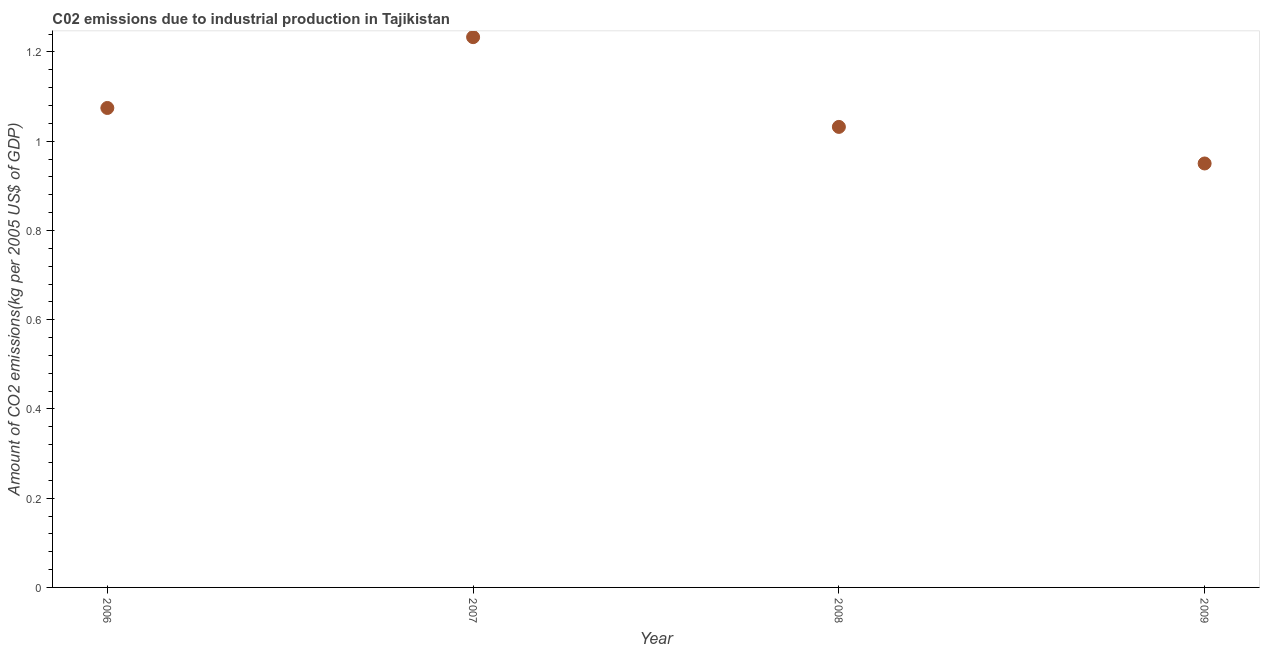What is the amount of co2 emissions in 2009?
Give a very brief answer. 0.95. Across all years, what is the maximum amount of co2 emissions?
Give a very brief answer. 1.23. Across all years, what is the minimum amount of co2 emissions?
Your response must be concise. 0.95. In which year was the amount of co2 emissions minimum?
Offer a terse response. 2009. What is the sum of the amount of co2 emissions?
Offer a very short reply. 4.29. What is the difference between the amount of co2 emissions in 2006 and 2009?
Your answer should be very brief. 0.12. What is the average amount of co2 emissions per year?
Your answer should be very brief. 1.07. What is the median amount of co2 emissions?
Keep it short and to the point. 1.05. Do a majority of the years between 2006 and 2008 (inclusive) have amount of co2 emissions greater than 0.56 kg per 2005 US$ of GDP?
Make the answer very short. Yes. What is the ratio of the amount of co2 emissions in 2007 to that in 2009?
Your response must be concise. 1.3. What is the difference between the highest and the second highest amount of co2 emissions?
Offer a terse response. 0.16. What is the difference between the highest and the lowest amount of co2 emissions?
Provide a succinct answer. 0.28. In how many years, is the amount of co2 emissions greater than the average amount of co2 emissions taken over all years?
Your response must be concise. 2. Does the amount of co2 emissions monotonically increase over the years?
Provide a short and direct response. No. How many dotlines are there?
Offer a very short reply. 1. How many years are there in the graph?
Your answer should be very brief. 4. What is the difference between two consecutive major ticks on the Y-axis?
Provide a short and direct response. 0.2. Does the graph contain grids?
Offer a terse response. No. What is the title of the graph?
Make the answer very short. C02 emissions due to industrial production in Tajikistan. What is the label or title of the X-axis?
Offer a terse response. Year. What is the label or title of the Y-axis?
Your response must be concise. Amount of CO2 emissions(kg per 2005 US$ of GDP). What is the Amount of CO2 emissions(kg per 2005 US$ of GDP) in 2006?
Ensure brevity in your answer.  1.07. What is the Amount of CO2 emissions(kg per 2005 US$ of GDP) in 2007?
Provide a short and direct response. 1.23. What is the Amount of CO2 emissions(kg per 2005 US$ of GDP) in 2008?
Keep it short and to the point. 1.03. What is the Amount of CO2 emissions(kg per 2005 US$ of GDP) in 2009?
Make the answer very short. 0.95. What is the difference between the Amount of CO2 emissions(kg per 2005 US$ of GDP) in 2006 and 2007?
Your answer should be compact. -0.16. What is the difference between the Amount of CO2 emissions(kg per 2005 US$ of GDP) in 2006 and 2008?
Your response must be concise. 0.04. What is the difference between the Amount of CO2 emissions(kg per 2005 US$ of GDP) in 2006 and 2009?
Keep it short and to the point. 0.12. What is the difference between the Amount of CO2 emissions(kg per 2005 US$ of GDP) in 2007 and 2008?
Offer a terse response. 0.2. What is the difference between the Amount of CO2 emissions(kg per 2005 US$ of GDP) in 2007 and 2009?
Your answer should be compact. 0.28. What is the difference between the Amount of CO2 emissions(kg per 2005 US$ of GDP) in 2008 and 2009?
Give a very brief answer. 0.08. What is the ratio of the Amount of CO2 emissions(kg per 2005 US$ of GDP) in 2006 to that in 2007?
Provide a succinct answer. 0.87. What is the ratio of the Amount of CO2 emissions(kg per 2005 US$ of GDP) in 2006 to that in 2008?
Provide a succinct answer. 1.04. What is the ratio of the Amount of CO2 emissions(kg per 2005 US$ of GDP) in 2006 to that in 2009?
Keep it short and to the point. 1.13. What is the ratio of the Amount of CO2 emissions(kg per 2005 US$ of GDP) in 2007 to that in 2008?
Your answer should be very brief. 1.2. What is the ratio of the Amount of CO2 emissions(kg per 2005 US$ of GDP) in 2007 to that in 2009?
Make the answer very short. 1.3. What is the ratio of the Amount of CO2 emissions(kg per 2005 US$ of GDP) in 2008 to that in 2009?
Provide a succinct answer. 1.09. 